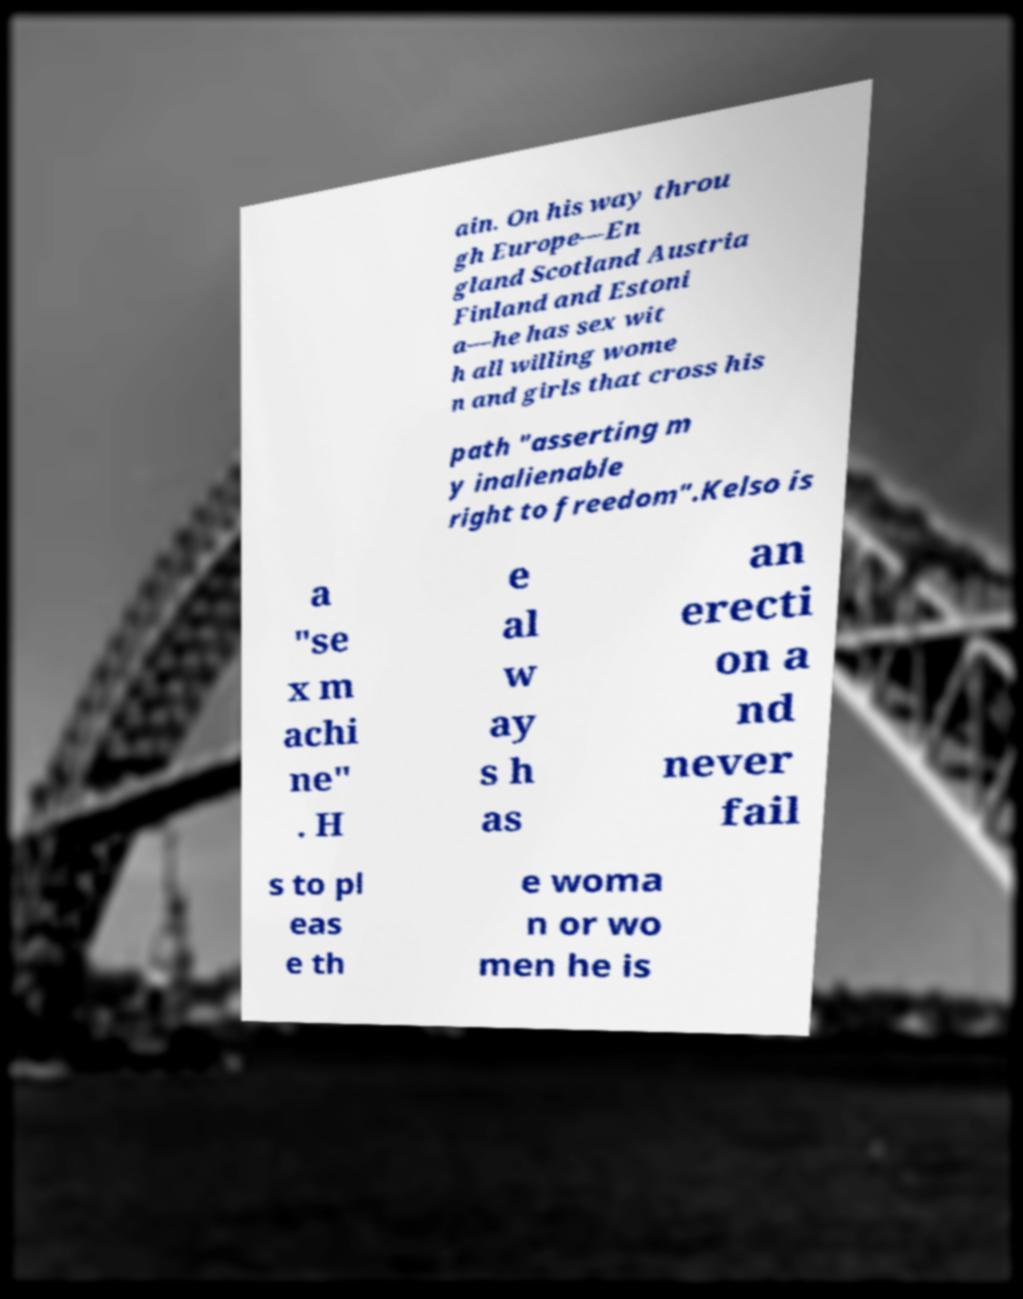Can you accurately transcribe the text from the provided image for me? ain. On his way throu gh Europe—En gland Scotland Austria Finland and Estoni a—he has sex wit h all willing wome n and girls that cross his path "asserting m y inalienable right to freedom".Kelso is a "se x m achi ne" . H e al w ay s h as an erecti on a nd never fail s to pl eas e th e woma n or wo men he is 